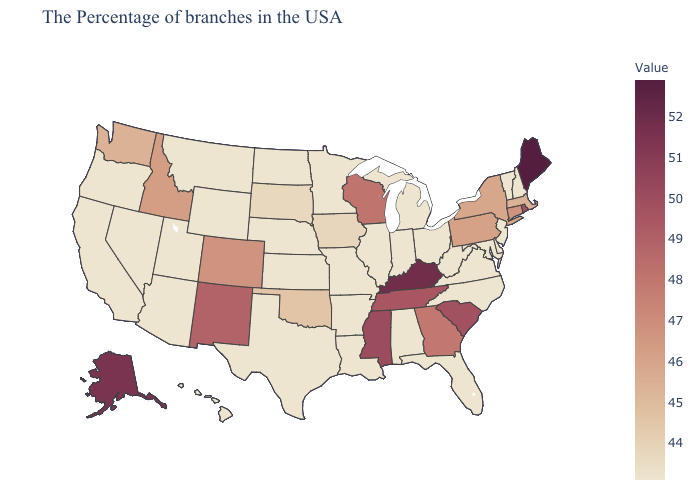Does Maine have the highest value in the USA?
Answer briefly. Yes. Which states hav the highest value in the MidWest?
Answer briefly. Wisconsin. Does Arizona have a higher value than Maine?
Short answer required. No. Among the states that border Arkansas , does Missouri have the lowest value?
Give a very brief answer. Yes. 